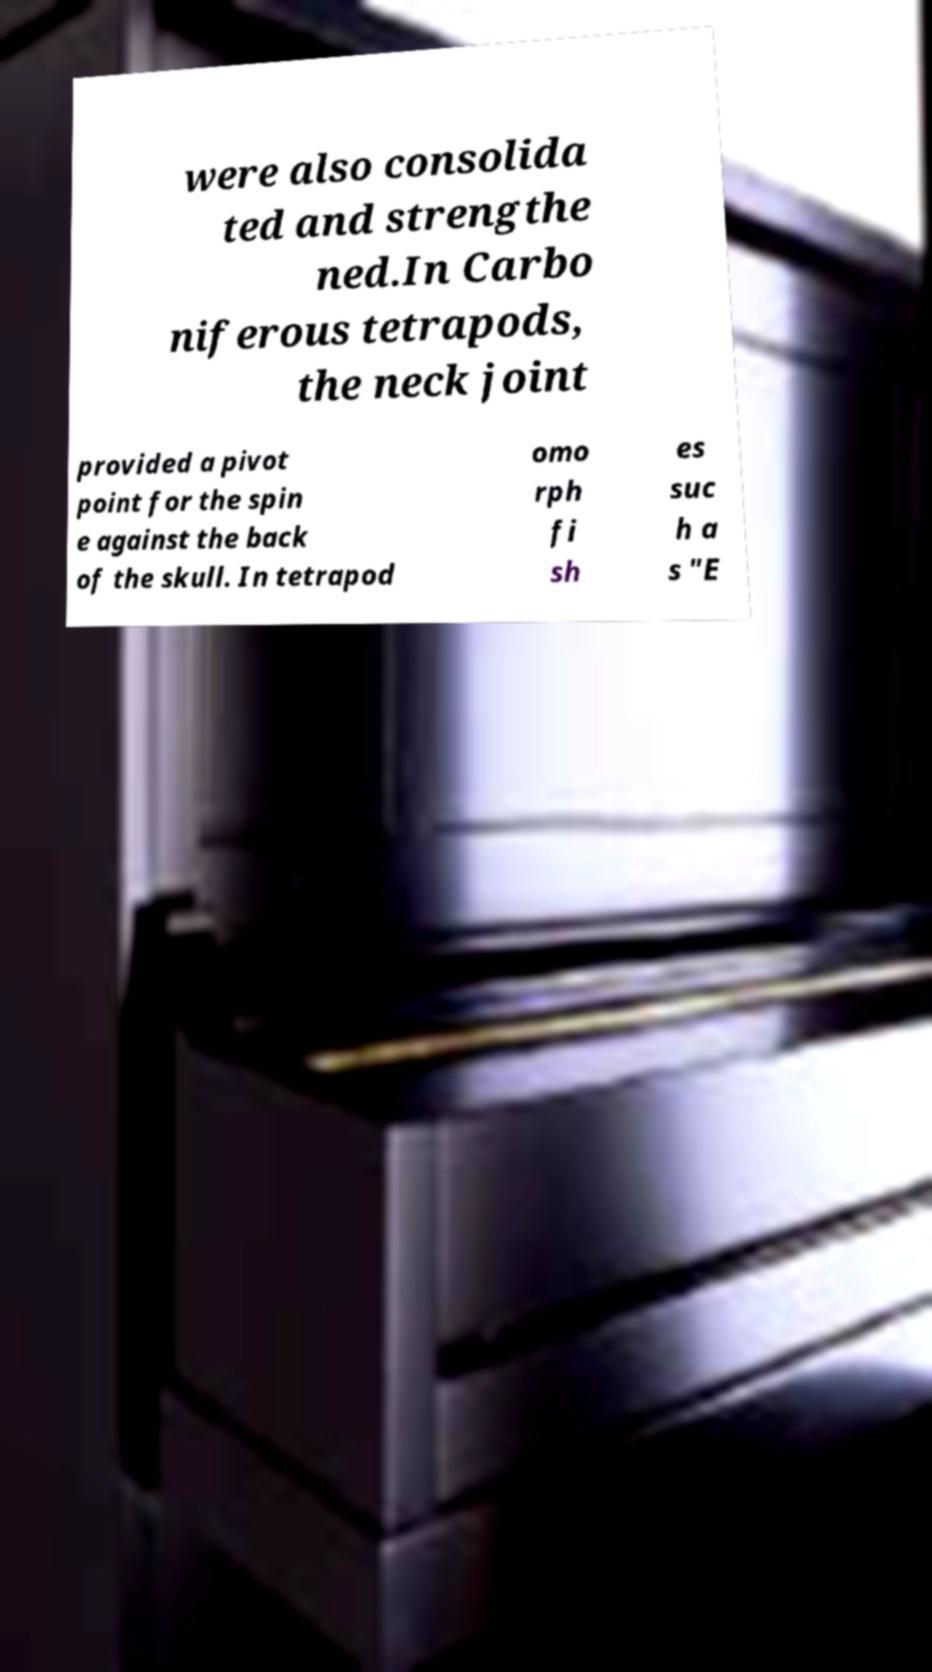I need the written content from this picture converted into text. Can you do that? were also consolida ted and strengthe ned.In Carbo niferous tetrapods, the neck joint provided a pivot point for the spin e against the back of the skull. In tetrapod omo rph fi sh es suc h a s "E 